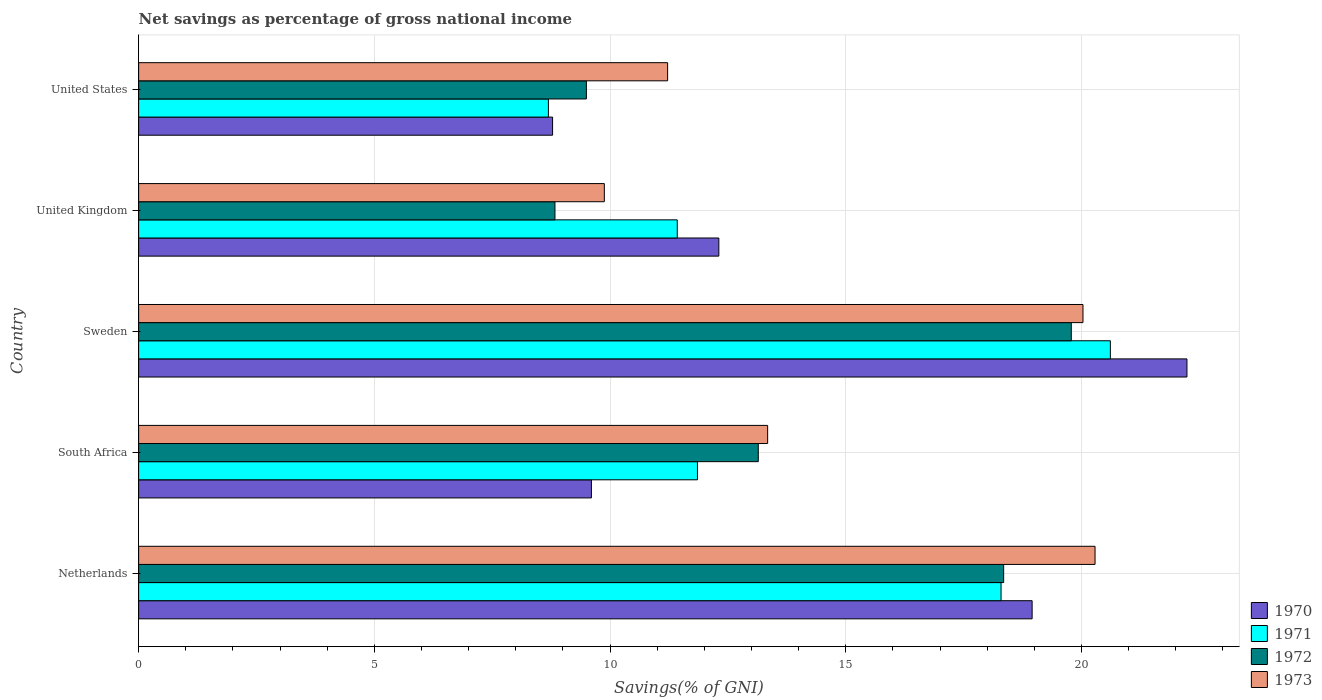How many different coloured bars are there?
Offer a terse response. 4. Are the number of bars on each tick of the Y-axis equal?
Your response must be concise. Yes. How many bars are there on the 4th tick from the bottom?
Offer a terse response. 4. What is the label of the 4th group of bars from the top?
Provide a succinct answer. South Africa. What is the total savings in 1973 in Sweden?
Your answer should be compact. 20.03. Across all countries, what is the maximum total savings in 1973?
Give a very brief answer. 20.29. Across all countries, what is the minimum total savings in 1972?
Offer a terse response. 8.83. In which country was the total savings in 1971 minimum?
Keep it short and to the point. United States. What is the total total savings in 1970 in the graph?
Make the answer very short. 71.88. What is the difference between the total savings in 1972 in Netherlands and that in South Africa?
Provide a succinct answer. 5.21. What is the difference between the total savings in 1971 in United States and the total savings in 1972 in Sweden?
Your answer should be very brief. -11.09. What is the average total savings in 1972 per country?
Provide a short and direct response. 13.92. What is the difference between the total savings in 1972 and total savings in 1970 in South Africa?
Your response must be concise. 3.54. In how many countries, is the total savings in 1973 greater than 19 %?
Keep it short and to the point. 2. What is the ratio of the total savings in 1972 in Netherlands to that in United Kingdom?
Offer a very short reply. 2.08. Is the difference between the total savings in 1972 in Sweden and United Kingdom greater than the difference between the total savings in 1970 in Sweden and United Kingdom?
Provide a succinct answer. Yes. What is the difference between the highest and the second highest total savings in 1970?
Your response must be concise. 3.28. What is the difference between the highest and the lowest total savings in 1971?
Offer a very short reply. 11.92. Is the sum of the total savings in 1973 in Netherlands and United Kingdom greater than the maximum total savings in 1972 across all countries?
Offer a terse response. Yes. Are all the bars in the graph horizontal?
Give a very brief answer. Yes. What is the difference between two consecutive major ticks on the X-axis?
Your answer should be compact. 5. Are the values on the major ticks of X-axis written in scientific E-notation?
Your answer should be compact. No. What is the title of the graph?
Offer a terse response. Net savings as percentage of gross national income. What is the label or title of the X-axis?
Your answer should be very brief. Savings(% of GNI). What is the Savings(% of GNI) in 1970 in Netherlands?
Make the answer very short. 18.95. What is the Savings(% of GNI) in 1971 in Netherlands?
Provide a succinct answer. 18.29. What is the Savings(% of GNI) in 1972 in Netherlands?
Make the answer very short. 18.35. What is the Savings(% of GNI) of 1973 in Netherlands?
Your answer should be compact. 20.29. What is the Savings(% of GNI) of 1970 in South Africa?
Provide a succinct answer. 9.6. What is the Savings(% of GNI) of 1971 in South Africa?
Ensure brevity in your answer.  11.85. What is the Savings(% of GNI) of 1972 in South Africa?
Make the answer very short. 13.14. What is the Savings(% of GNI) in 1973 in South Africa?
Provide a short and direct response. 13.34. What is the Savings(% of GNI) in 1970 in Sweden?
Offer a very short reply. 22.24. What is the Savings(% of GNI) in 1971 in Sweden?
Provide a short and direct response. 20.61. What is the Savings(% of GNI) of 1972 in Sweden?
Your answer should be compact. 19.78. What is the Savings(% of GNI) in 1973 in Sweden?
Keep it short and to the point. 20.03. What is the Savings(% of GNI) of 1970 in United Kingdom?
Offer a terse response. 12.31. What is the Savings(% of GNI) of 1971 in United Kingdom?
Keep it short and to the point. 11.43. What is the Savings(% of GNI) in 1972 in United Kingdom?
Your answer should be very brief. 8.83. What is the Savings(% of GNI) of 1973 in United Kingdom?
Provide a succinct answer. 9.88. What is the Savings(% of GNI) in 1970 in United States?
Offer a very short reply. 8.78. What is the Savings(% of GNI) in 1971 in United States?
Provide a short and direct response. 8.69. What is the Savings(% of GNI) in 1972 in United States?
Ensure brevity in your answer.  9.5. What is the Savings(% of GNI) of 1973 in United States?
Offer a very short reply. 11.22. Across all countries, what is the maximum Savings(% of GNI) in 1970?
Offer a very short reply. 22.24. Across all countries, what is the maximum Savings(% of GNI) in 1971?
Ensure brevity in your answer.  20.61. Across all countries, what is the maximum Savings(% of GNI) in 1972?
Provide a short and direct response. 19.78. Across all countries, what is the maximum Savings(% of GNI) in 1973?
Your answer should be very brief. 20.29. Across all countries, what is the minimum Savings(% of GNI) in 1970?
Give a very brief answer. 8.78. Across all countries, what is the minimum Savings(% of GNI) of 1971?
Give a very brief answer. 8.69. Across all countries, what is the minimum Savings(% of GNI) of 1972?
Keep it short and to the point. 8.83. Across all countries, what is the minimum Savings(% of GNI) of 1973?
Your answer should be compact. 9.88. What is the total Savings(% of GNI) in 1970 in the graph?
Your answer should be compact. 71.88. What is the total Savings(% of GNI) in 1971 in the graph?
Keep it short and to the point. 70.88. What is the total Savings(% of GNI) in 1972 in the graph?
Keep it short and to the point. 69.61. What is the total Savings(% of GNI) in 1973 in the graph?
Give a very brief answer. 74.76. What is the difference between the Savings(% of GNI) in 1970 in Netherlands and that in South Africa?
Provide a succinct answer. 9.35. What is the difference between the Savings(% of GNI) of 1971 in Netherlands and that in South Africa?
Ensure brevity in your answer.  6.44. What is the difference between the Savings(% of GNI) in 1972 in Netherlands and that in South Africa?
Offer a very short reply. 5.21. What is the difference between the Savings(% of GNI) of 1973 in Netherlands and that in South Africa?
Your response must be concise. 6.95. What is the difference between the Savings(% of GNI) of 1970 in Netherlands and that in Sweden?
Provide a short and direct response. -3.28. What is the difference between the Savings(% of GNI) of 1971 in Netherlands and that in Sweden?
Keep it short and to the point. -2.32. What is the difference between the Savings(% of GNI) of 1972 in Netherlands and that in Sweden?
Provide a short and direct response. -1.43. What is the difference between the Savings(% of GNI) of 1973 in Netherlands and that in Sweden?
Your answer should be compact. 0.26. What is the difference between the Savings(% of GNI) of 1970 in Netherlands and that in United Kingdom?
Your response must be concise. 6.65. What is the difference between the Savings(% of GNI) in 1971 in Netherlands and that in United Kingdom?
Offer a very short reply. 6.87. What is the difference between the Savings(% of GNI) of 1972 in Netherlands and that in United Kingdom?
Your response must be concise. 9.52. What is the difference between the Savings(% of GNI) of 1973 in Netherlands and that in United Kingdom?
Make the answer very short. 10.41. What is the difference between the Savings(% of GNI) of 1970 in Netherlands and that in United States?
Make the answer very short. 10.17. What is the difference between the Savings(% of GNI) in 1971 in Netherlands and that in United States?
Keep it short and to the point. 9.6. What is the difference between the Savings(% of GNI) in 1972 in Netherlands and that in United States?
Ensure brevity in your answer.  8.85. What is the difference between the Savings(% of GNI) in 1973 in Netherlands and that in United States?
Make the answer very short. 9.07. What is the difference between the Savings(% of GNI) of 1970 in South Africa and that in Sweden?
Make the answer very short. -12.63. What is the difference between the Savings(% of GNI) in 1971 in South Africa and that in Sweden?
Keep it short and to the point. -8.76. What is the difference between the Savings(% of GNI) of 1972 in South Africa and that in Sweden?
Provide a short and direct response. -6.64. What is the difference between the Savings(% of GNI) of 1973 in South Africa and that in Sweden?
Your answer should be very brief. -6.69. What is the difference between the Savings(% of GNI) in 1970 in South Africa and that in United Kingdom?
Keep it short and to the point. -2.7. What is the difference between the Savings(% of GNI) in 1971 in South Africa and that in United Kingdom?
Offer a very short reply. 0.43. What is the difference between the Savings(% of GNI) of 1972 in South Africa and that in United Kingdom?
Make the answer very short. 4.31. What is the difference between the Savings(% of GNI) of 1973 in South Africa and that in United Kingdom?
Offer a terse response. 3.46. What is the difference between the Savings(% of GNI) in 1970 in South Africa and that in United States?
Your response must be concise. 0.82. What is the difference between the Savings(% of GNI) in 1971 in South Africa and that in United States?
Offer a very short reply. 3.16. What is the difference between the Savings(% of GNI) in 1972 in South Africa and that in United States?
Ensure brevity in your answer.  3.65. What is the difference between the Savings(% of GNI) in 1973 in South Africa and that in United States?
Your response must be concise. 2.12. What is the difference between the Savings(% of GNI) in 1970 in Sweden and that in United Kingdom?
Keep it short and to the point. 9.93. What is the difference between the Savings(% of GNI) of 1971 in Sweden and that in United Kingdom?
Provide a short and direct response. 9.19. What is the difference between the Savings(% of GNI) in 1972 in Sweden and that in United Kingdom?
Offer a very short reply. 10.95. What is the difference between the Savings(% of GNI) of 1973 in Sweden and that in United Kingdom?
Offer a terse response. 10.15. What is the difference between the Savings(% of GNI) of 1970 in Sweden and that in United States?
Offer a very short reply. 13.46. What is the difference between the Savings(% of GNI) in 1971 in Sweden and that in United States?
Provide a succinct answer. 11.92. What is the difference between the Savings(% of GNI) in 1972 in Sweden and that in United States?
Your response must be concise. 10.29. What is the difference between the Savings(% of GNI) in 1973 in Sweden and that in United States?
Give a very brief answer. 8.81. What is the difference between the Savings(% of GNI) in 1970 in United Kingdom and that in United States?
Ensure brevity in your answer.  3.53. What is the difference between the Savings(% of GNI) of 1971 in United Kingdom and that in United States?
Your answer should be compact. 2.73. What is the difference between the Savings(% of GNI) in 1972 in United Kingdom and that in United States?
Offer a very short reply. -0.67. What is the difference between the Savings(% of GNI) of 1973 in United Kingdom and that in United States?
Offer a terse response. -1.34. What is the difference between the Savings(% of GNI) of 1970 in Netherlands and the Savings(% of GNI) of 1971 in South Africa?
Offer a terse response. 7.1. What is the difference between the Savings(% of GNI) of 1970 in Netherlands and the Savings(% of GNI) of 1972 in South Africa?
Your answer should be compact. 5.81. What is the difference between the Savings(% of GNI) of 1970 in Netherlands and the Savings(% of GNI) of 1973 in South Africa?
Your answer should be very brief. 5.61. What is the difference between the Savings(% of GNI) of 1971 in Netherlands and the Savings(% of GNI) of 1972 in South Africa?
Your answer should be very brief. 5.15. What is the difference between the Savings(% of GNI) of 1971 in Netherlands and the Savings(% of GNI) of 1973 in South Africa?
Keep it short and to the point. 4.95. What is the difference between the Savings(% of GNI) of 1972 in Netherlands and the Savings(% of GNI) of 1973 in South Africa?
Your response must be concise. 5.01. What is the difference between the Savings(% of GNI) in 1970 in Netherlands and the Savings(% of GNI) in 1971 in Sweden?
Your answer should be very brief. -1.66. What is the difference between the Savings(% of GNI) in 1970 in Netherlands and the Savings(% of GNI) in 1972 in Sweden?
Give a very brief answer. -0.83. What is the difference between the Savings(% of GNI) of 1970 in Netherlands and the Savings(% of GNI) of 1973 in Sweden?
Your answer should be very brief. -1.08. What is the difference between the Savings(% of GNI) in 1971 in Netherlands and the Savings(% of GNI) in 1972 in Sweden?
Give a very brief answer. -1.49. What is the difference between the Savings(% of GNI) of 1971 in Netherlands and the Savings(% of GNI) of 1973 in Sweden?
Provide a succinct answer. -1.74. What is the difference between the Savings(% of GNI) in 1972 in Netherlands and the Savings(% of GNI) in 1973 in Sweden?
Your answer should be very brief. -1.68. What is the difference between the Savings(% of GNI) in 1970 in Netherlands and the Savings(% of GNI) in 1971 in United Kingdom?
Make the answer very short. 7.53. What is the difference between the Savings(% of GNI) in 1970 in Netherlands and the Savings(% of GNI) in 1972 in United Kingdom?
Offer a terse response. 10.12. What is the difference between the Savings(% of GNI) of 1970 in Netherlands and the Savings(% of GNI) of 1973 in United Kingdom?
Your answer should be very brief. 9.07. What is the difference between the Savings(% of GNI) in 1971 in Netherlands and the Savings(% of GNI) in 1972 in United Kingdom?
Provide a succinct answer. 9.46. What is the difference between the Savings(% of GNI) of 1971 in Netherlands and the Savings(% of GNI) of 1973 in United Kingdom?
Make the answer very short. 8.42. What is the difference between the Savings(% of GNI) in 1972 in Netherlands and the Savings(% of GNI) in 1973 in United Kingdom?
Offer a very short reply. 8.47. What is the difference between the Savings(% of GNI) in 1970 in Netherlands and the Savings(% of GNI) in 1971 in United States?
Make the answer very short. 10.26. What is the difference between the Savings(% of GNI) of 1970 in Netherlands and the Savings(% of GNI) of 1972 in United States?
Your answer should be compact. 9.46. What is the difference between the Savings(% of GNI) of 1970 in Netherlands and the Savings(% of GNI) of 1973 in United States?
Make the answer very short. 7.73. What is the difference between the Savings(% of GNI) in 1971 in Netherlands and the Savings(% of GNI) in 1972 in United States?
Provide a succinct answer. 8.8. What is the difference between the Savings(% of GNI) in 1971 in Netherlands and the Savings(% of GNI) in 1973 in United States?
Provide a short and direct response. 7.07. What is the difference between the Savings(% of GNI) of 1972 in Netherlands and the Savings(% of GNI) of 1973 in United States?
Ensure brevity in your answer.  7.13. What is the difference between the Savings(% of GNI) in 1970 in South Africa and the Savings(% of GNI) in 1971 in Sweden?
Ensure brevity in your answer.  -11.01. What is the difference between the Savings(% of GNI) in 1970 in South Africa and the Savings(% of GNI) in 1972 in Sweden?
Keep it short and to the point. -10.18. What is the difference between the Savings(% of GNI) of 1970 in South Africa and the Savings(% of GNI) of 1973 in Sweden?
Keep it short and to the point. -10.43. What is the difference between the Savings(% of GNI) in 1971 in South Africa and the Savings(% of GNI) in 1972 in Sweden?
Provide a succinct answer. -7.93. What is the difference between the Savings(% of GNI) of 1971 in South Africa and the Savings(% of GNI) of 1973 in Sweden?
Offer a terse response. -8.18. What is the difference between the Savings(% of GNI) of 1972 in South Africa and the Savings(% of GNI) of 1973 in Sweden?
Keep it short and to the point. -6.89. What is the difference between the Savings(% of GNI) of 1970 in South Africa and the Savings(% of GNI) of 1971 in United Kingdom?
Give a very brief answer. -1.82. What is the difference between the Savings(% of GNI) in 1970 in South Africa and the Savings(% of GNI) in 1972 in United Kingdom?
Provide a short and direct response. 0.77. What is the difference between the Savings(% of GNI) of 1970 in South Africa and the Savings(% of GNI) of 1973 in United Kingdom?
Your answer should be very brief. -0.27. What is the difference between the Savings(% of GNI) of 1971 in South Africa and the Savings(% of GNI) of 1972 in United Kingdom?
Ensure brevity in your answer.  3.02. What is the difference between the Savings(% of GNI) in 1971 in South Africa and the Savings(% of GNI) in 1973 in United Kingdom?
Offer a terse response. 1.98. What is the difference between the Savings(% of GNI) in 1972 in South Africa and the Savings(% of GNI) in 1973 in United Kingdom?
Provide a short and direct response. 3.27. What is the difference between the Savings(% of GNI) in 1970 in South Africa and the Savings(% of GNI) in 1971 in United States?
Ensure brevity in your answer.  0.91. What is the difference between the Savings(% of GNI) in 1970 in South Africa and the Savings(% of GNI) in 1972 in United States?
Provide a succinct answer. 0.11. What is the difference between the Savings(% of GNI) of 1970 in South Africa and the Savings(% of GNI) of 1973 in United States?
Offer a very short reply. -1.62. What is the difference between the Savings(% of GNI) of 1971 in South Africa and the Savings(% of GNI) of 1972 in United States?
Offer a terse response. 2.36. What is the difference between the Savings(% of GNI) in 1971 in South Africa and the Savings(% of GNI) in 1973 in United States?
Keep it short and to the point. 0.63. What is the difference between the Savings(% of GNI) in 1972 in South Africa and the Savings(% of GNI) in 1973 in United States?
Offer a very short reply. 1.92. What is the difference between the Savings(% of GNI) of 1970 in Sweden and the Savings(% of GNI) of 1971 in United Kingdom?
Offer a very short reply. 10.81. What is the difference between the Savings(% of GNI) of 1970 in Sweden and the Savings(% of GNI) of 1972 in United Kingdom?
Your response must be concise. 13.41. What is the difference between the Savings(% of GNI) of 1970 in Sweden and the Savings(% of GNI) of 1973 in United Kingdom?
Your response must be concise. 12.36. What is the difference between the Savings(% of GNI) in 1971 in Sweden and the Savings(% of GNI) in 1972 in United Kingdom?
Offer a terse response. 11.78. What is the difference between the Savings(% of GNI) in 1971 in Sweden and the Savings(% of GNI) in 1973 in United Kingdom?
Your response must be concise. 10.73. What is the difference between the Savings(% of GNI) of 1972 in Sweden and the Savings(% of GNI) of 1973 in United Kingdom?
Keep it short and to the point. 9.91. What is the difference between the Savings(% of GNI) of 1970 in Sweden and the Savings(% of GNI) of 1971 in United States?
Your answer should be compact. 13.54. What is the difference between the Savings(% of GNI) in 1970 in Sweden and the Savings(% of GNI) in 1972 in United States?
Offer a very short reply. 12.74. What is the difference between the Savings(% of GNI) of 1970 in Sweden and the Savings(% of GNI) of 1973 in United States?
Provide a short and direct response. 11.02. What is the difference between the Savings(% of GNI) of 1971 in Sweden and the Savings(% of GNI) of 1972 in United States?
Your answer should be very brief. 11.12. What is the difference between the Savings(% of GNI) of 1971 in Sweden and the Savings(% of GNI) of 1973 in United States?
Provide a succinct answer. 9.39. What is the difference between the Savings(% of GNI) in 1972 in Sweden and the Savings(% of GNI) in 1973 in United States?
Provide a succinct answer. 8.56. What is the difference between the Savings(% of GNI) in 1970 in United Kingdom and the Savings(% of GNI) in 1971 in United States?
Your answer should be very brief. 3.62. What is the difference between the Savings(% of GNI) in 1970 in United Kingdom and the Savings(% of GNI) in 1972 in United States?
Keep it short and to the point. 2.81. What is the difference between the Savings(% of GNI) of 1970 in United Kingdom and the Savings(% of GNI) of 1973 in United States?
Your response must be concise. 1.09. What is the difference between the Savings(% of GNI) in 1971 in United Kingdom and the Savings(% of GNI) in 1972 in United States?
Give a very brief answer. 1.93. What is the difference between the Savings(% of GNI) in 1971 in United Kingdom and the Savings(% of GNI) in 1973 in United States?
Your answer should be compact. 0.2. What is the difference between the Savings(% of GNI) in 1972 in United Kingdom and the Savings(% of GNI) in 1973 in United States?
Provide a short and direct response. -2.39. What is the average Savings(% of GNI) of 1970 per country?
Provide a short and direct response. 14.38. What is the average Savings(% of GNI) of 1971 per country?
Keep it short and to the point. 14.18. What is the average Savings(% of GNI) in 1972 per country?
Offer a very short reply. 13.92. What is the average Savings(% of GNI) in 1973 per country?
Provide a succinct answer. 14.95. What is the difference between the Savings(% of GNI) of 1970 and Savings(% of GNI) of 1971 in Netherlands?
Offer a terse response. 0.66. What is the difference between the Savings(% of GNI) of 1970 and Savings(% of GNI) of 1972 in Netherlands?
Provide a short and direct response. 0.6. What is the difference between the Savings(% of GNI) in 1970 and Savings(% of GNI) in 1973 in Netherlands?
Provide a succinct answer. -1.33. What is the difference between the Savings(% of GNI) of 1971 and Savings(% of GNI) of 1972 in Netherlands?
Provide a short and direct response. -0.06. What is the difference between the Savings(% of GNI) of 1971 and Savings(% of GNI) of 1973 in Netherlands?
Offer a terse response. -1.99. What is the difference between the Savings(% of GNI) of 1972 and Savings(% of GNI) of 1973 in Netherlands?
Offer a terse response. -1.94. What is the difference between the Savings(% of GNI) of 1970 and Savings(% of GNI) of 1971 in South Africa?
Your answer should be very brief. -2.25. What is the difference between the Savings(% of GNI) in 1970 and Savings(% of GNI) in 1972 in South Africa?
Make the answer very short. -3.54. What is the difference between the Savings(% of GNI) in 1970 and Savings(% of GNI) in 1973 in South Africa?
Your answer should be very brief. -3.74. What is the difference between the Savings(% of GNI) of 1971 and Savings(% of GNI) of 1972 in South Africa?
Provide a succinct answer. -1.29. What is the difference between the Savings(% of GNI) in 1971 and Savings(% of GNI) in 1973 in South Africa?
Offer a very short reply. -1.49. What is the difference between the Savings(% of GNI) of 1972 and Savings(% of GNI) of 1973 in South Africa?
Your answer should be compact. -0.2. What is the difference between the Savings(% of GNI) of 1970 and Savings(% of GNI) of 1971 in Sweden?
Your answer should be very brief. 1.62. What is the difference between the Savings(% of GNI) in 1970 and Savings(% of GNI) in 1972 in Sweden?
Provide a succinct answer. 2.45. What is the difference between the Savings(% of GNI) of 1970 and Savings(% of GNI) of 1973 in Sweden?
Your response must be concise. 2.21. What is the difference between the Savings(% of GNI) in 1971 and Savings(% of GNI) in 1972 in Sweden?
Your answer should be compact. 0.83. What is the difference between the Savings(% of GNI) of 1971 and Savings(% of GNI) of 1973 in Sweden?
Your response must be concise. 0.58. What is the difference between the Savings(% of GNI) in 1972 and Savings(% of GNI) in 1973 in Sweden?
Keep it short and to the point. -0.25. What is the difference between the Savings(% of GNI) in 1970 and Savings(% of GNI) in 1971 in United Kingdom?
Your response must be concise. 0.88. What is the difference between the Savings(% of GNI) of 1970 and Savings(% of GNI) of 1972 in United Kingdom?
Provide a succinct answer. 3.48. What is the difference between the Savings(% of GNI) in 1970 and Savings(% of GNI) in 1973 in United Kingdom?
Offer a very short reply. 2.43. What is the difference between the Savings(% of GNI) of 1971 and Savings(% of GNI) of 1972 in United Kingdom?
Your answer should be compact. 2.59. What is the difference between the Savings(% of GNI) in 1971 and Savings(% of GNI) in 1973 in United Kingdom?
Ensure brevity in your answer.  1.55. What is the difference between the Savings(% of GNI) of 1972 and Savings(% of GNI) of 1973 in United Kingdom?
Your answer should be compact. -1.05. What is the difference between the Savings(% of GNI) in 1970 and Savings(% of GNI) in 1971 in United States?
Your answer should be very brief. 0.09. What is the difference between the Savings(% of GNI) in 1970 and Savings(% of GNI) in 1972 in United States?
Your answer should be very brief. -0.72. What is the difference between the Savings(% of GNI) in 1970 and Savings(% of GNI) in 1973 in United States?
Your answer should be very brief. -2.44. What is the difference between the Savings(% of GNI) of 1971 and Savings(% of GNI) of 1972 in United States?
Ensure brevity in your answer.  -0.81. What is the difference between the Savings(% of GNI) in 1971 and Savings(% of GNI) in 1973 in United States?
Give a very brief answer. -2.53. What is the difference between the Savings(% of GNI) of 1972 and Savings(% of GNI) of 1973 in United States?
Offer a terse response. -1.72. What is the ratio of the Savings(% of GNI) in 1970 in Netherlands to that in South Africa?
Ensure brevity in your answer.  1.97. What is the ratio of the Savings(% of GNI) in 1971 in Netherlands to that in South Africa?
Make the answer very short. 1.54. What is the ratio of the Savings(% of GNI) of 1972 in Netherlands to that in South Africa?
Keep it short and to the point. 1.4. What is the ratio of the Savings(% of GNI) of 1973 in Netherlands to that in South Africa?
Offer a terse response. 1.52. What is the ratio of the Savings(% of GNI) of 1970 in Netherlands to that in Sweden?
Keep it short and to the point. 0.85. What is the ratio of the Savings(% of GNI) of 1971 in Netherlands to that in Sweden?
Offer a terse response. 0.89. What is the ratio of the Savings(% of GNI) in 1972 in Netherlands to that in Sweden?
Your answer should be compact. 0.93. What is the ratio of the Savings(% of GNI) in 1973 in Netherlands to that in Sweden?
Your answer should be compact. 1.01. What is the ratio of the Savings(% of GNI) in 1970 in Netherlands to that in United Kingdom?
Provide a succinct answer. 1.54. What is the ratio of the Savings(% of GNI) of 1971 in Netherlands to that in United Kingdom?
Ensure brevity in your answer.  1.6. What is the ratio of the Savings(% of GNI) in 1972 in Netherlands to that in United Kingdom?
Provide a succinct answer. 2.08. What is the ratio of the Savings(% of GNI) of 1973 in Netherlands to that in United Kingdom?
Provide a short and direct response. 2.05. What is the ratio of the Savings(% of GNI) in 1970 in Netherlands to that in United States?
Offer a terse response. 2.16. What is the ratio of the Savings(% of GNI) in 1971 in Netherlands to that in United States?
Provide a succinct answer. 2.1. What is the ratio of the Savings(% of GNI) in 1972 in Netherlands to that in United States?
Make the answer very short. 1.93. What is the ratio of the Savings(% of GNI) in 1973 in Netherlands to that in United States?
Offer a very short reply. 1.81. What is the ratio of the Savings(% of GNI) of 1970 in South Africa to that in Sweden?
Ensure brevity in your answer.  0.43. What is the ratio of the Savings(% of GNI) of 1971 in South Africa to that in Sweden?
Ensure brevity in your answer.  0.58. What is the ratio of the Savings(% of GNI) in 1972 in South Africa to that in Sweden?
Offer a terse response. 0.66. What is the ratio of the Savings(% of GNI) in 1973 in South Africa to that in Sweden?
Give a very brief answer. 0.67. What is the ratio of the Savings(% of GNI) of 1970 in South Africa to that in United Kingdom?
Offer a terse response. 0.78. What is the ratio of the Savings(% of GNI) in 1971 in South Africa to that in United Kingdom?
Make the answer very short. 1.04. What is the ratio of the Savings(% of GNI) in 1972 in South Africa to that in United Kingdom?
Offer a very short reply. 1.49. What is the ratio of the Savings(% of GNI) of 1973 in South Africa to that in United Kingdom?
Make the answer very short. 1.35. What is the ratio of the Savings(% of GNI) in 1970 in South Africa to that in United States?
Give a very brief answer. 1.09. What is the ratio of the Savings(% of GNI) of 1971 in South Africa to that in United States?
Offer a very short reply. 1.36. What is the ratio of the Savings(% of GNI) in 1972 in South Africa to that in United States?
Ensure brevity in your answer.  1.38. What is the ratio of the Savings(% of GNI) of 1973 in South Africa to that in United States?
Your answer should be very brief. 1.19. What is the ratio of the Savings(% of GNI) in 1970 in Sweden to that in United Kingdom?
Your answer should be compact. 1.81. What is the ratio of the Savings(% of GNI) of 1971 in Sweden to that in United Kingdom?
Provide a succinct answer. 1.8. What is the ratio of the Savings(% of GNI) of 1972 in Sweden to that in United Kingdom?
Give a very brief answer. 2.24. What is the ratio of the Savings(% of GNI) in 1973 in Sweden to that in United Kingdom?
Your answer should be compact. 2.03. What is the ratio of the Savings(% of GNI) of 1970 in Sweden to that in United States?
Offer a very short reply. 2.53. What is the ratio of the Savings(% of GNI) in 1971 in Sweden to that in United States?
Provide a succinct answer. 2.37. What is the ratio of the Savings(% of GNI) in 1972 in Sweden to that in United States?
Keep it short and to the point. 2.08. What is the ratio of the Savings(% of GNI) in 1973 in Sweden to that in United States?
Keep it short and to the point. 1.79. What is the ratio of the Savings(% of GNI) of 1970 in United Kingdom to that in United States?
Give a very brief answer. 1.4. What is the ratio of the Savings(% of GNI) in 1971 in United Kingdom to that in United States?
Keep it short and to the point. 1.31. What is the ratio of the Savings(% of GNI) of 1972 in United Kingdom to that in United States?
Your answer should be very brief. 0.93. What is the ratio of the Savings(% of GNI) of 1973 in United Kingdom to that in United States?
Provide a short and direct response. 0.88. What is the difference between the highest and the second highest Savings(% of GNI) of 1970?
Your response must be concise. 3.28. What is the difference between the highest and the second highest Savings(% of GNI) in 1971?
Offer a very short reply. 2.32. What is the difference between the highest and the second highest Savings(% of GNI) in 1972?
Give a very brief answer. 1.43. What is the difference between the highest and the second highest Savings(% of GNI) in 1973?
Make the answer very short. 0.26. What is the difference between the highest and the lowest Savings(% of GNI) in 1970?
Give a very brief answer. 13.46. What is the difference between the highest and the lowest Savings(% of GNI) of 1971?
Provide a succinct answer. 11.92. What is the difference between the highest and the lowest Savings(% of GNI) of 1972?
Provide a succinct answer. 10.95. What is the difference between the highest and the lowest Savings(% of GNI) of 1973?
Ensure brevity in your answer.  10.41. 